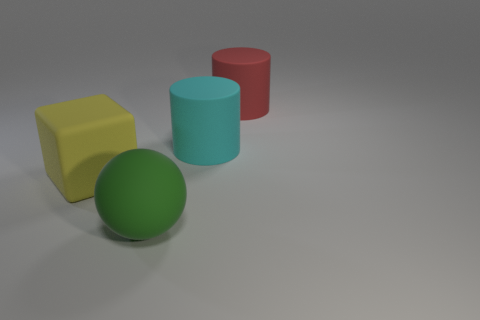Add 1 large gray metallic spheres. How many objects exist? 5 Subtract all balls. How many objects are left? 3 Subtract all green things. Subtract all yellow cubes. How many objects are left? 2 Add 4 matte blocks. How many matte blocks are left? 5 Add 2 big purple metallic cylinders. How many big purple metallic cylinders exist? 2 Subtract 0 purple cubes. How many objects are left? 4 